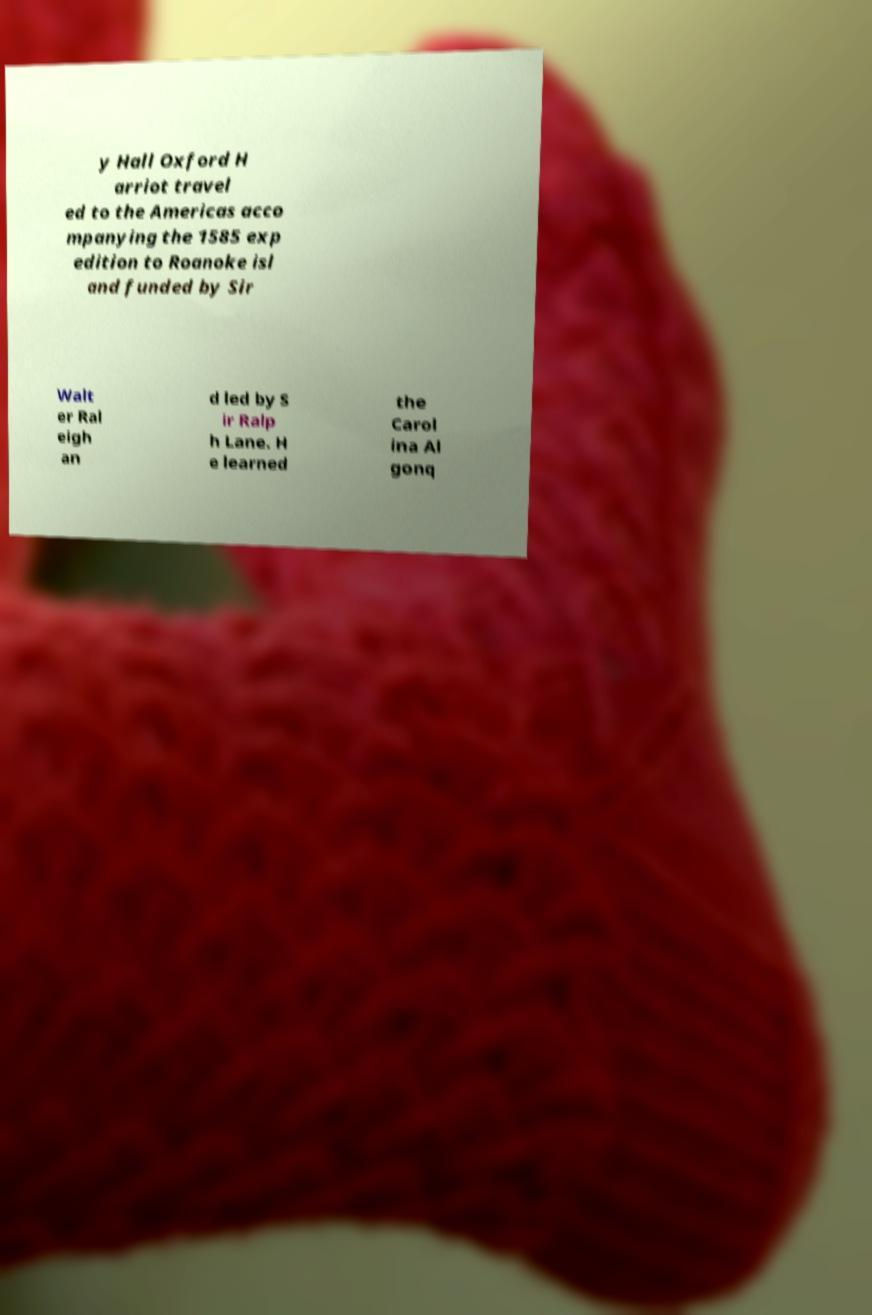Please identify and transcribe the text found in this image. y Hall Oxford H arriot travel ed to the Americas acco mpanying the 1585 exp edition to Roanoke isl and funded by Sir Walt er Ral eigh an d led by S ir Ralp h Lane. H e learned the Carol ina Al gonq 